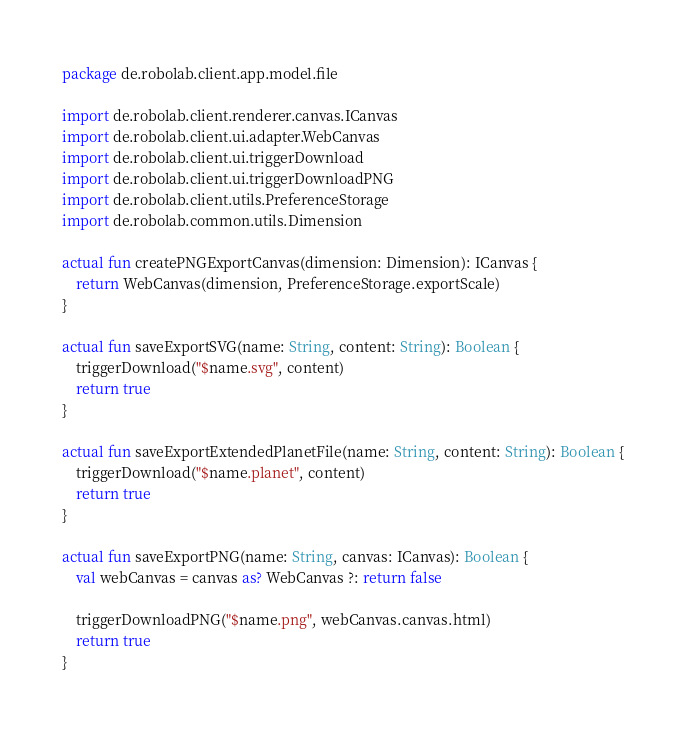Convert code to text. <code><loc_0><loc_0><loc_500><loc_500><_Kotlin_>package de.robolab.client.app.model.file

import de.robolab.client.renderer.canvas.ICanvas
import de.robolab.client.ui.adapter.WebCanvas
import de.robolab.client.ui.triggerDownload
import de.robolab.client.ui.triggerDownloadPNG
import de.robolab.client.utils.PreferenceStorage
import de.robolab.common.utils.Dimension

actual fun createPNGExportCanvas(dimension: Dimension): ICanvas {
    return WebCanvas(dimension, PreferenceStorage.exportScale)
}

actual fun saveExportSVG(name: String, content: String): Boolean {
    triggerDownload("$name.svg", content)
    return true
}

actual fun saveExportExtendedPlanetFile(name: String, content: String): Boolean {
    triggerDownload("$name.planet", content)
    return true
}

actual fun saveExportPNG(name: String, canvas: ICanvas): Boolean {
    val webCanvas = canvas as? WebCanvas ?: return false

    triggerDownloadPNG("$name.png", webCanvas.canvas.html)
    return true
}
</code> 